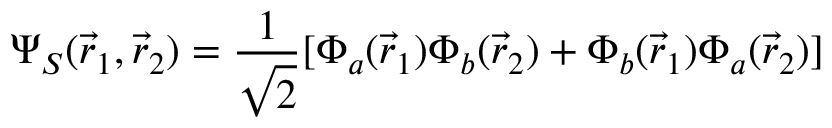<formula> <loc_0><loc_0><loc_500><loc_500>\Psi _ { S } ( { \vec { r } } _ { 1 } , { \vec { r } } _ { 2 } ) = { \frac { 1 } { \sqrt { 2 } } } [ \Phi _ { a } ( { \vec { r } } _ { 1 } ) \Phi _ { b } ( { \vec { r } } _ { 2 } ) + \Phi _ { b } ( { \vec { r } } _ { 1 } ) \Phi _ { a } ( { \vec { r } } _ { 2 } ) ]</formula> 